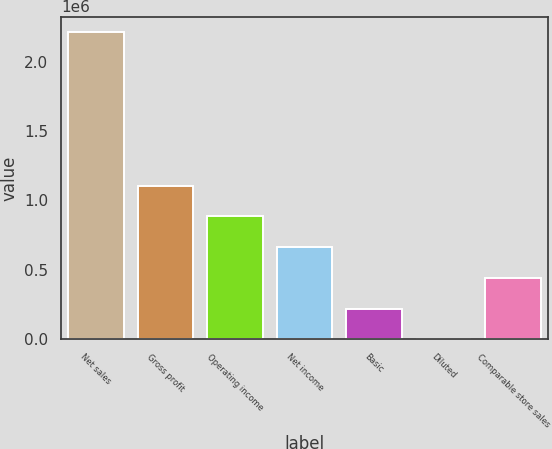<chart> <loc_0><loc_0><loc_500><loc_500><bar_chart><fcel>Net sales<fcel>Gross profit<fcel>Operating income<fcel>Net income<fcel>Basic<fcel>Diluted<fcel>Comparable store sales<nl><fcel>2.21325e+06<fcel>1.10663e+06<fcel>885301<fcel>663976<fcel>221326<fcel>1.69<fcel>442651<nl></chart> 